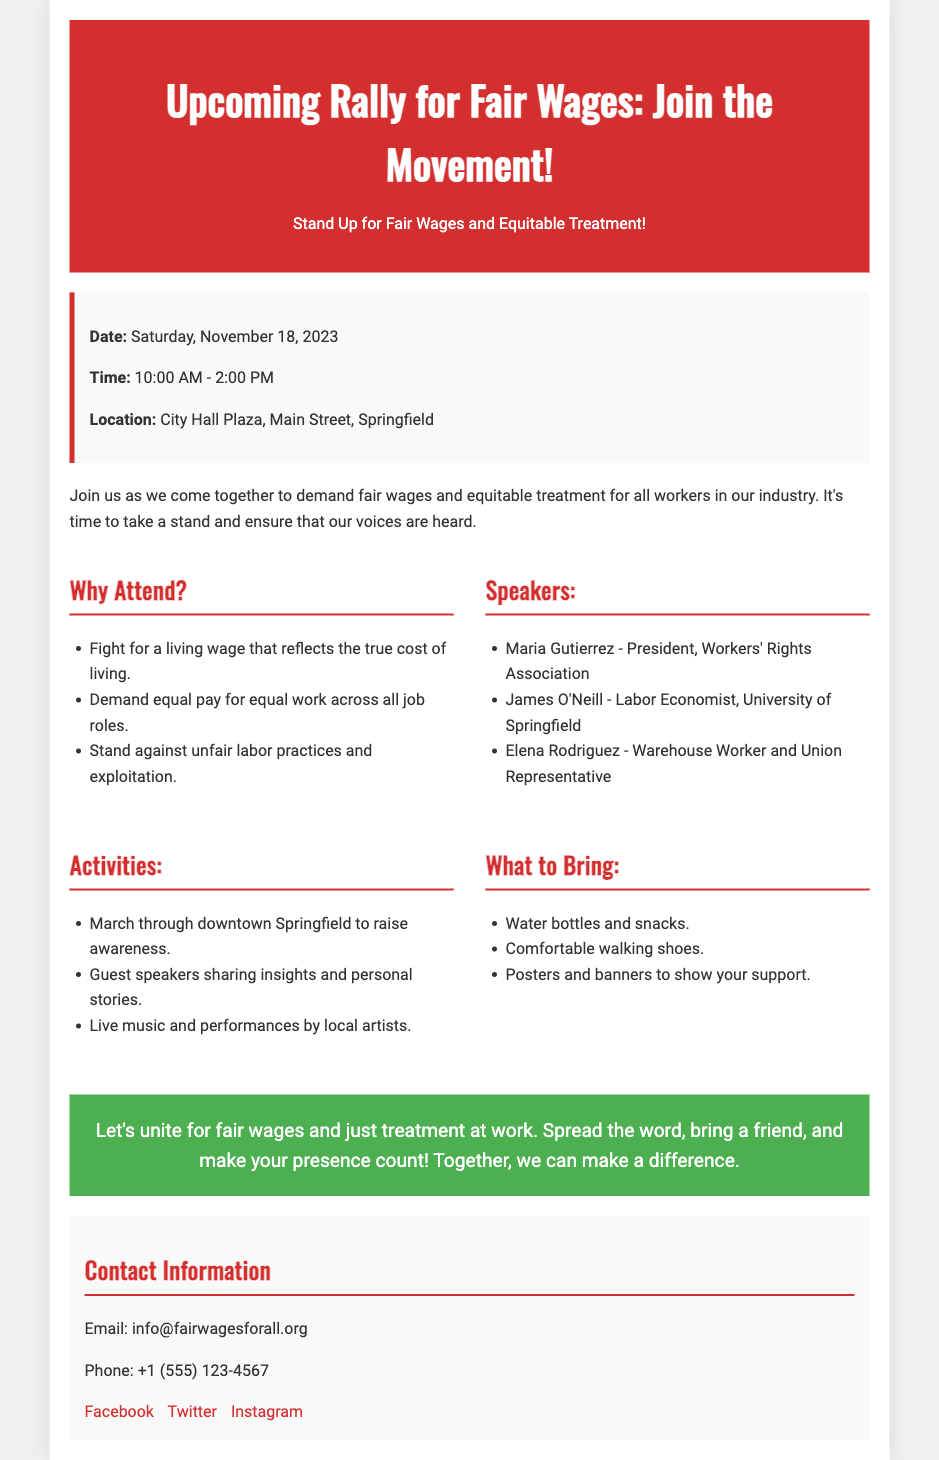What is the date of the rally? The date of the rally is explicitly stated in the event details section of the document.
Answer: Saturday, November 18, 2023 What time does the rally start? The starting time of the rally is listed in the event details as well.
Answer: 10:00 AM Where is the rally taking place? The location of the rally is mentioned in the event details section, specifying where attendees should gather.
Answer: City Hall Plaza, Main Street, Springfield Who is one of the featured speakers? The speakers are listed under their respective section, showcasing notable individuals who will be addressing the attendees.
Answer: Maria Gutierrez What should attendees bring? The "What to Bring" section outlines specific items that participants are encouraged to take to the rally.
Answer: Water bottles and snacks Why is the rally being held? The purpose of the rally is addressed in the introductory paragraph, emphasizing the main cause for gathering.
Answer: Fair wages and equitable treatment What type of activities will occur at the rally? Activities are detailed in their respective section, providing insight into what participants can expect during the event.
Answer: March through downtown Springfield What organization is sending out the contact information? The contact information section specifies the organization associated with the rally and how to reach them.
Answer: Fair Wages For All 